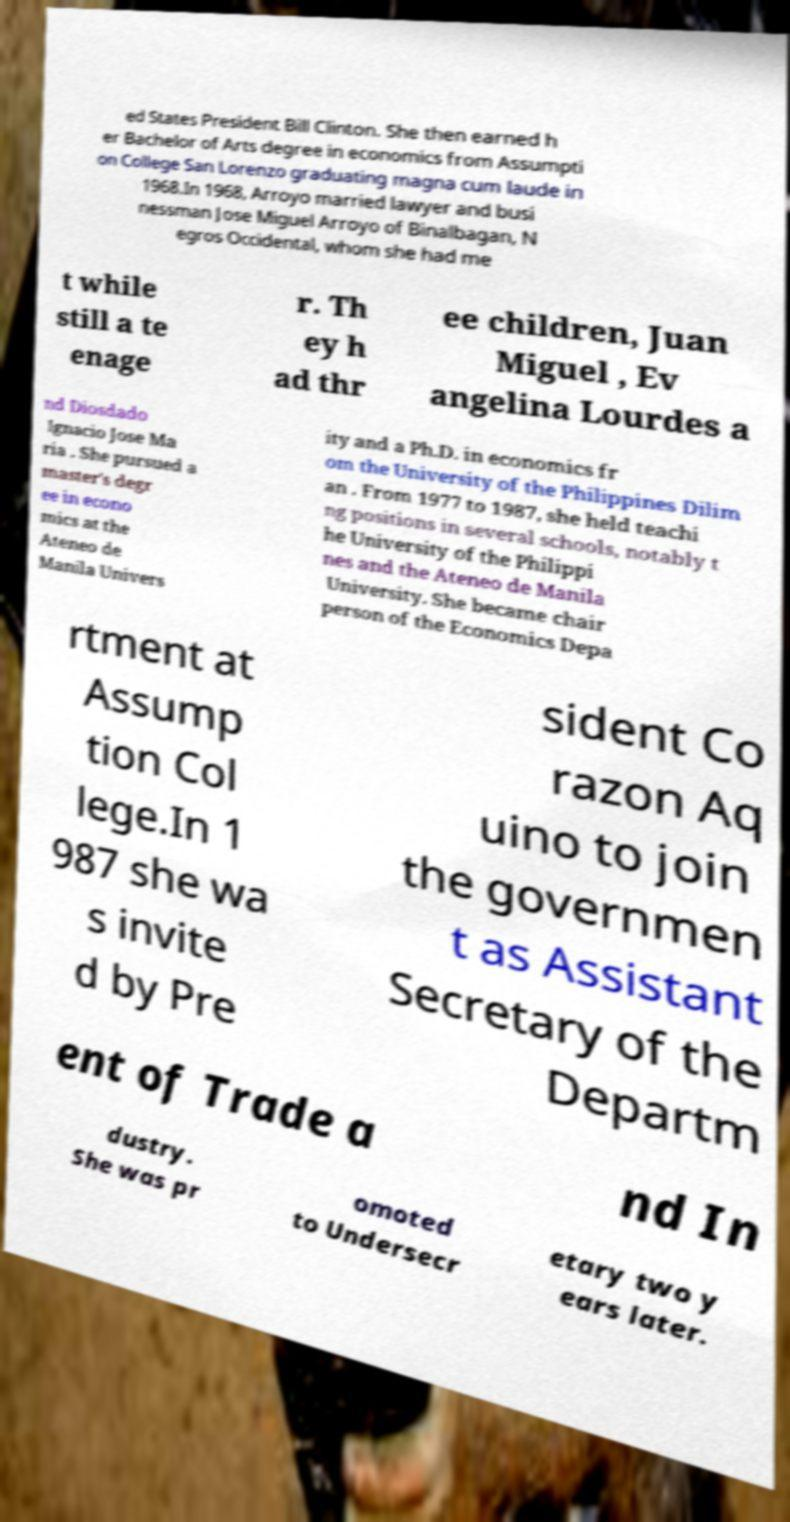What messages or text are displayed in this image? I need them in a readable, typed format. ed States President Bill Clinton. She then earned h er Bachelor of Arts degree in economics from Assumpti on College San Lorenzo graduating magna cum laude in 1968.In 1968, Arroyo married lawyer and busi nessman Jose Miguel Arroyo of Binalbagan, N egros Occidental, whom she had me t while still a te enage r. Th ey h ad thr ee children, Juan Miguel , Ev angelina Lourdes a nd Diosdado Ignacio Jose Ma ria . She pursued a master's degr ee in econo mics at the Ateneo de Manila Univers ity and a Ph.D. in economics fr om the University of the Philippines Dilim an . From 1977 to 1987, she held teachi ng positions in several schools, notably t he University of the Philippi nes and the Ateneo de Manila University. She became chair person of the Economics Depa rtment at Assump tion Col lege.In 1 987 she wa s invite d by Pre sident Co razon Aq uino to join the governmen t as Assistant Secretary of the Departm ent of Trade a nd In dustry. She was pr omoted to Undersecr etary two y ears later. 